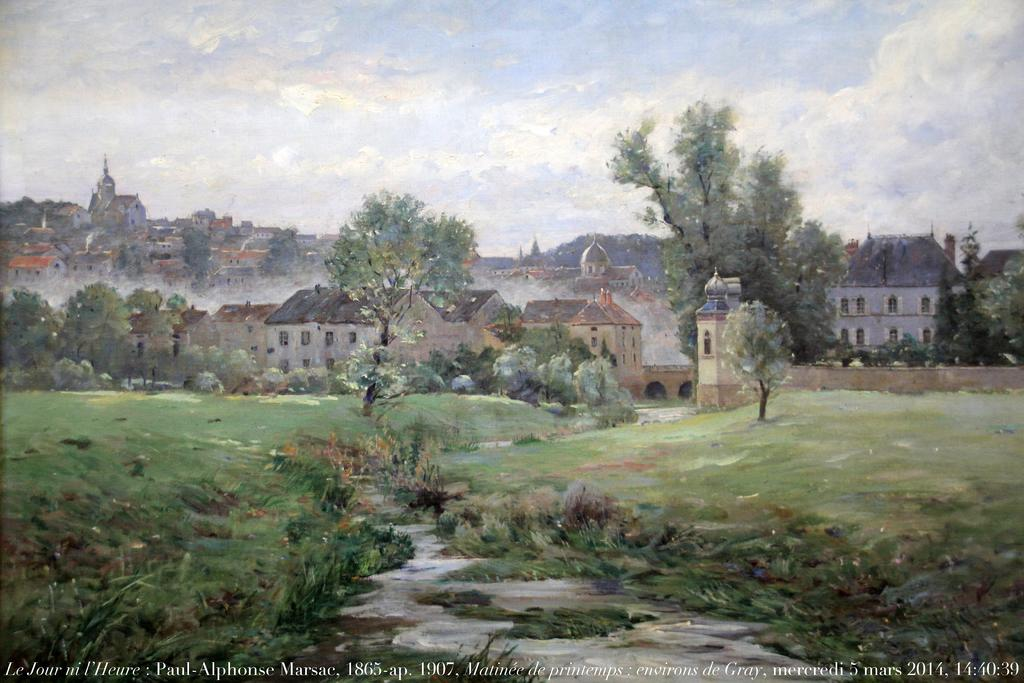What is in the foreground of the image? There is water and grass in the foreground of the image. What can be seen in the background of the image? There are buildings, trees, and the sky visible in the background of the image. What type of advice can be seen written on the rod in the image? There is no rod or advice present in the image. Is the park visible in the image? The provided facts do not mention a park, so it cannot be determined if a park is visible in the image. 